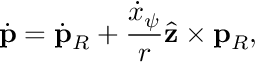<formula> <loc_0><loc_0><loc_500><loc_500>\dot { p } = \dot { p } _ { R } + \frac { \dot { x } _ { \psi } } { r } \hat { z } \times p _ { R } ,</formula> 